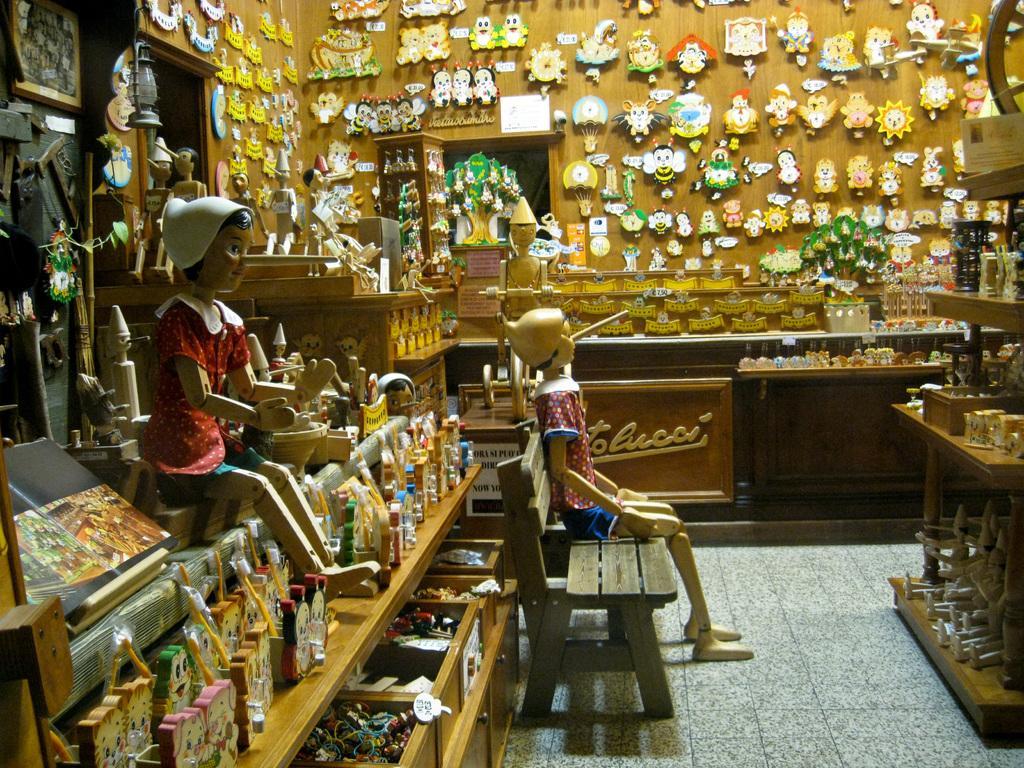Could you give a brief overview of what you see in this image? Here we can see dolls present and one doll is sitting on a bench present in the middle and this total looks like a toy shop 